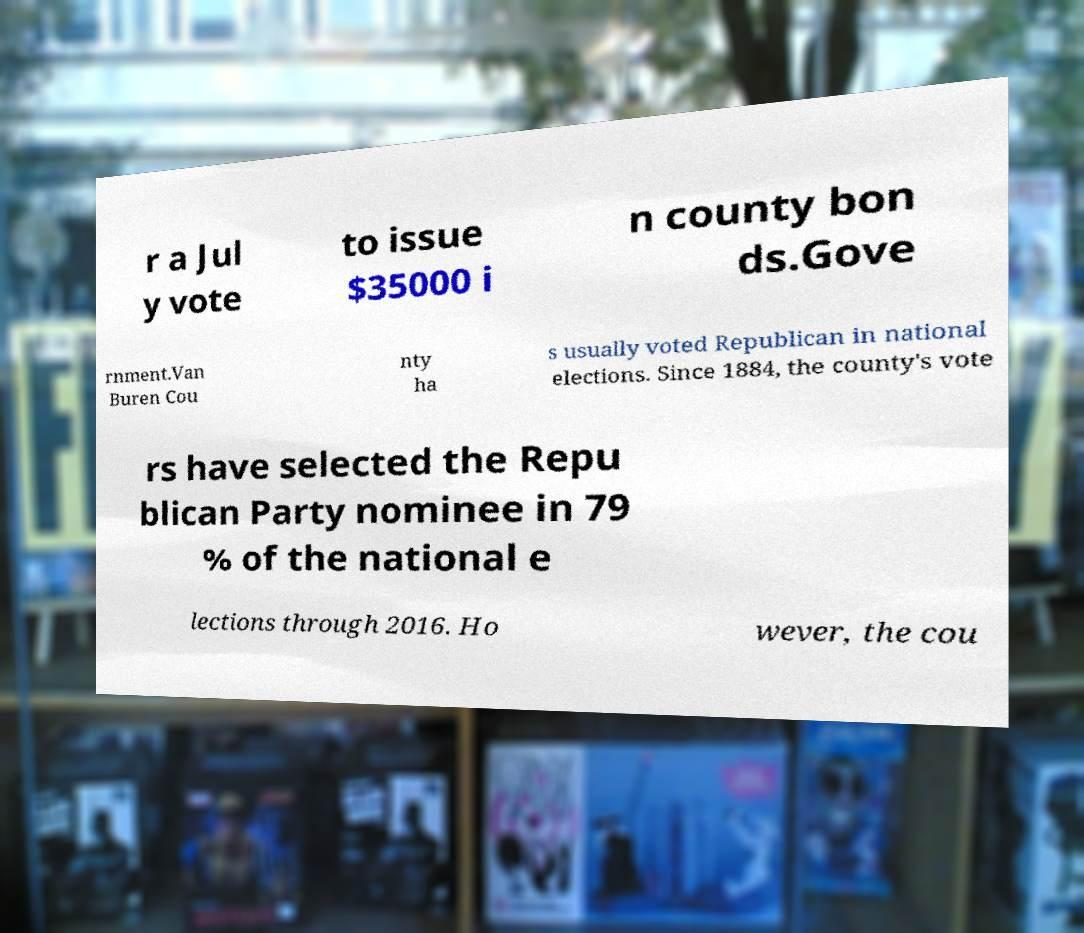I need the written content from this picture converted into text. Can you do that? r a Jul y vote to issue $35000 i n county bon ds.Gove rnment.Van Buren Cou nty ha s usually voted Republican in national elections. Since 1884, the county's vote rs have selected the Repu blican Party nominee in 79 % of the national e lections through 2016. Ho wever, the cou 